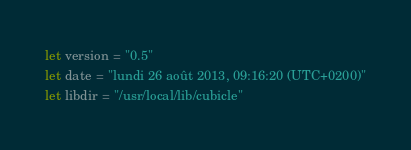Convert code to text. <code><loc_0><loc_0><loc_500><loc_500><_OCaml_>let version = "0.5"
let date = "lundi 26 août 2013, 09:16:20 (UTC+0200)"
let libdir = "/usr/local/lib/cubicle"
</code> 